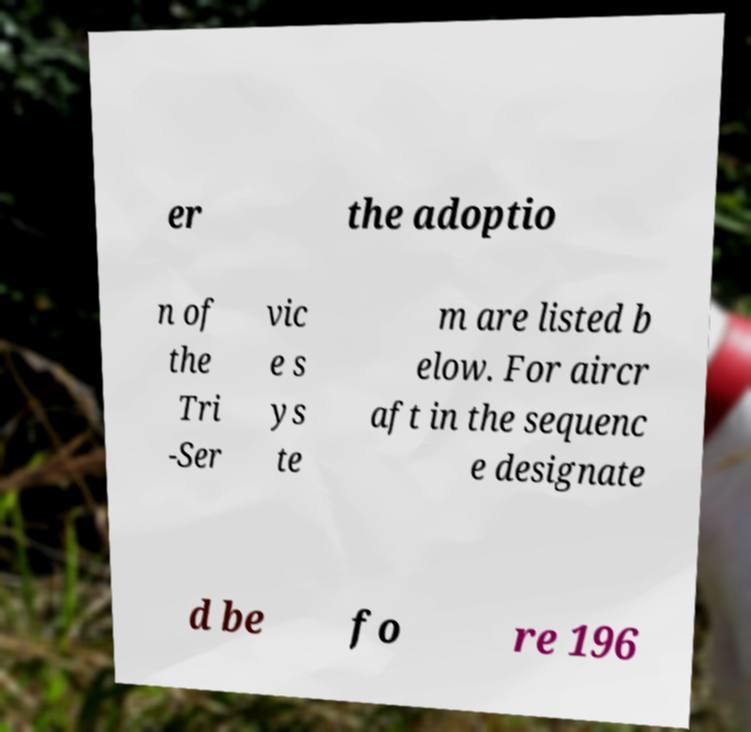For documentation purposes, I need the text within this image transcribed. Could you provide that? er the adoptio n of the Tri -Ser vic e s ys te m are listed b elow. For aircr aft in the sequenc e designate d be fo re 196 